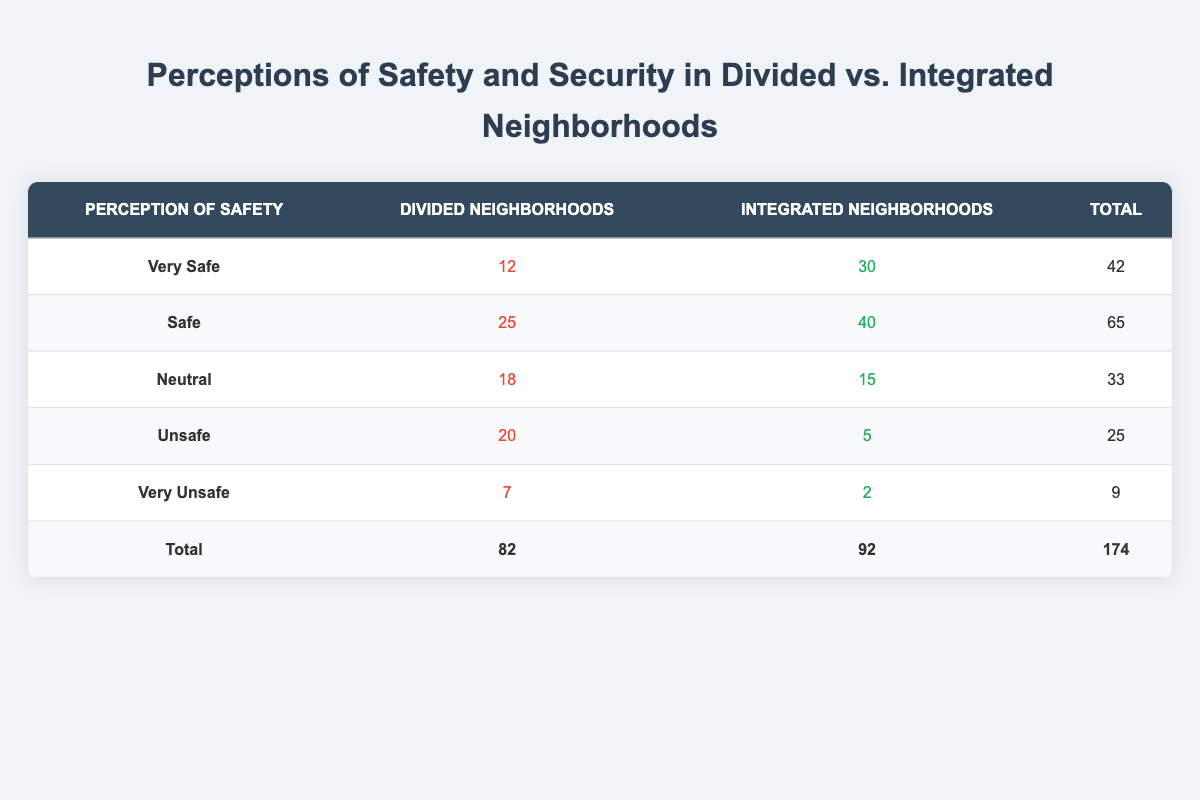What is the total number of respondents in integrated neighborhoods? To find the total number of respondents in integrated neighborhoods, we sum the counts from all perception categories for integrated neighborhoods: 30 (Very Safe) + 40 (Safe) + 15 (Neutral) + 5 (Unsafe) + 2 (Very Unsafe) = 92.
Answer: 92 How many respondents feel "Unsafe" in divided neighborhoods? Looking directly at the table, the count of respondents who feel "Unsafe" in divided neighborhoods is given as 20.
Answer: 20 What is the total count of respondents who feel "Very Safe" across both neighborhood types? To get this total, we add the counts from both neighborhood types: 12 (Divided) + 30 (Integrated) = 42.
Answer: 42 Is the perception of safety "Very Unsafe" higher in divided neighborhoods compared to integrated neighborhoods? In divided neighborhoods, the count of "Very Unsafe" respondents is 7, while in integrated neighborhoods it is 2. Since 7 is greater than 2, the perception of "Very Unsafe" is indeed higher in divided neighborhoods.
Answer: Yes What percentage of respondents in integrated neighborhoods feel "Safe"? To find the percentage of respondents who feel "Safe" in integrated neighborhoods, we take the count of "Safe" (40), divide by the total count of respondents in integrated neighborhoods (92), and multiply by 100: (40/92) * 100 ≈ 43.48%.
Answer: 43.48% What is the difference in the number of respondents who feel "Neutral" between the two neighborhood types? The number of "Neutral" respondents in divided neighborhoods is 18, while in integrated neighborhoods it is 15. The difference is calculated by subtracting: 18 - 15 = 3.
Answer: 3 How many total respondents feel "Unsafe" across both neighborhood types? We gather the counts of "Unsafe" from both totals: 20 (Divided) + 5 (Integrated) = 25.
Answer: 25 What is the average perception of safety score across divided neighborhoods? Assigning scores based on perception categories (Very Safe=5, Safe=4, Neutral=3, Unsafe=2, Very Unsafe=1), we calculate the weighted average: (12*5 + 25*4 + 18*3 + 20*2 + 7*1) / 82 = (60 + 100 + 54 + 40 + 7) / 82 = 261 / 82 ≈ 3.18.
Answer: 3.18 Are there more respondents who feel "Safe" than those who feel "Unsafe" in divided neighborhoods? From the table, 25 respondents feel "Safe" while 20 respondents feel "Unsafe". Since 25 is greater than 20, there are indeed more respondents who feel "Safe".
Answer: Yes 